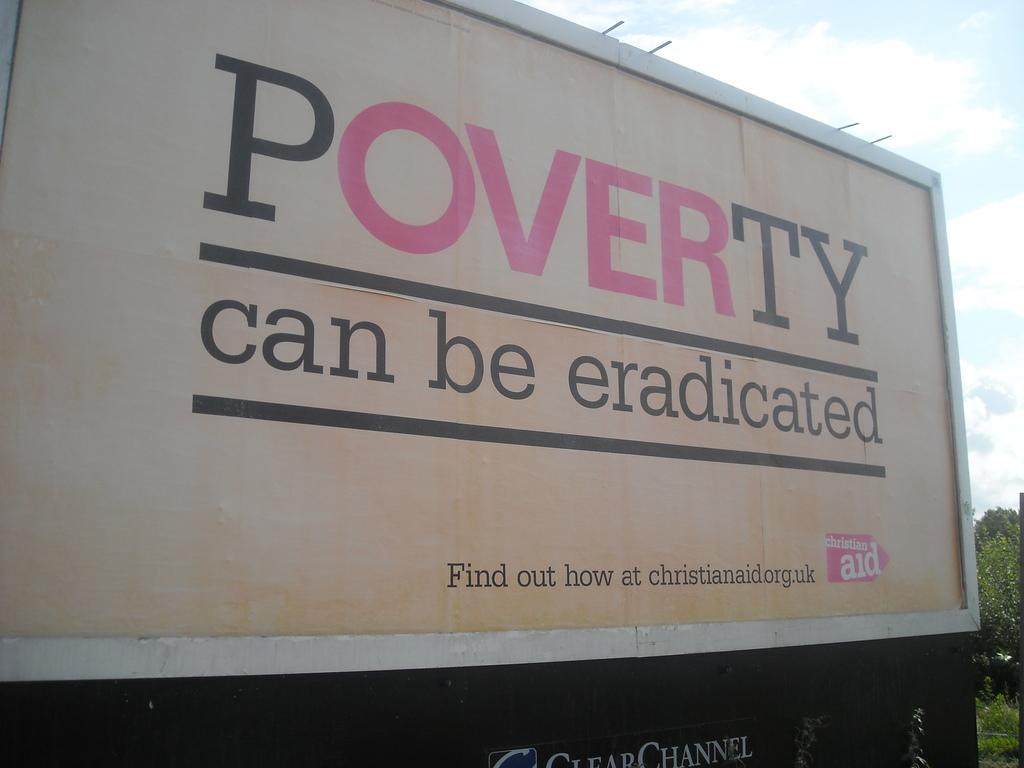What is the url they want you to go to?
Your answer should be very brief. Christianaid.org.uk. 